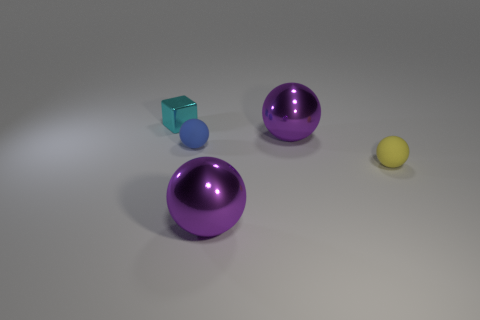Subtract all purple balls. Subtract all blue cylinders. How many balls are left? 2 Add 4 yellow things. How many objects exist? 9 Subtract all blocks. How many objects are left? 4 Subtract all blue balls. Subtract all tiny blue cubes. How many objects are left? 4 Add 5 small yellow rubber objects. How many small yellow rubber objects are left? 6 Add 5 brown metallic cylinders. How many brown metallic cylinders exist? 5 Subtract 0 yellow cylinders. How many objects are left? 5 